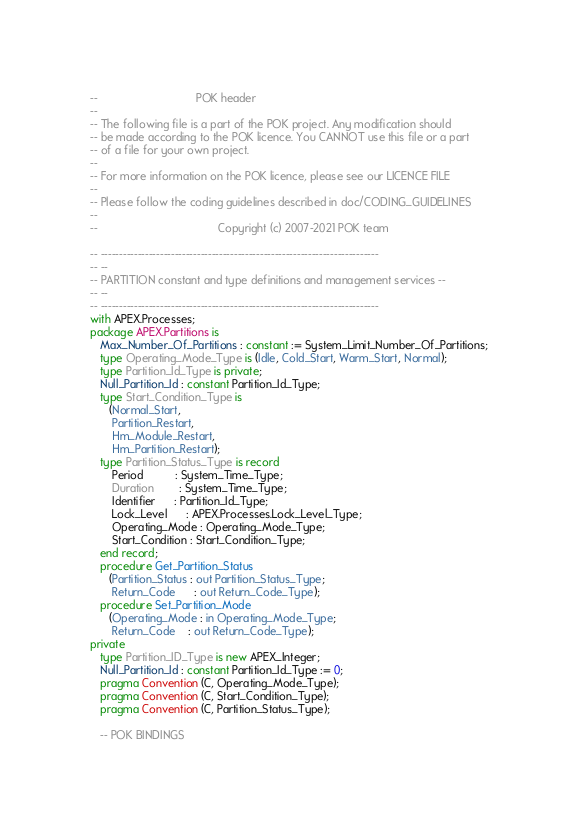<code> <loc_0><loc_0><loc_500><loc_500><_Ada_>--                               POK header
--
-- The following file is a part of the POK project. Any modification should
-- be made according to the POK licence. You CANNOT use this file or a part
-- of a file for your own project.
--
-- For more information on the POK licence, please see our LICENCE FILE
--
-- Please follow the coding guidelines described in doc/CODING_GUIDELINES
--
--                                      Copyright (c) 2007-2021 POK team

-- ---------------------------------------------------------------------------
-- --
-- PARTITION constant and type definitions and management services --
-- --
-- ---------------------------------------------------------------------------
with APEX.Processes;
package APEX.Partitions is
   Max_Number_Of_Partitions : constant := System_Limit_Number_Of_Partitions;
   type Operating_Mode_Type is (Idle, Cold_Start, Warm_Start, Normal);
   type Partition_Id_Type is private;
   Null_Partition_Id : constant Partition_Id_Type;
   type Start_Condition_Type is
      (Normal_Start,
       Partition_Restart,
       Hm_Module_Restart,
       Hm_Partition_Restart);
   type Partition_Status_Type is record
       Period          : System_Time_Type;
       Duration        : System_Time_Type;
       Identifier      : Partition_Id_Type;
       Lock_Level      : APEX.Processes.Lock_Level_Type;
       Operating_Mode : Operating_Mode_Type;
       Start_Condition : Start_Condition_Type;
   end record;
   procedure Get_Partition_Status
      (Partition_Status : out Partition_Status_Type;
       Return_Code      : out Return_Code_Type);
   procedure Set_Partition_Mode
      (Operating_Mode : in Operating_Mode_Type;
       Return_Code    : out Return_Code_Type);
private
   type Partition_ID_Type is new APEX_Integer;
   Null_Partition_Id : constant Partition_Id_Type := 0;
   pragma Convention (C, Operating_Mode_Type);
   pragma Convention (C, Start_Condition_Type);
   pragma Convention (C, Partition_Status_Type);

   -- POK BINDINGS</code> 